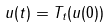Convert formula to latex. <formula><loc_0><loc_0><loc_500><loc_500>u ( t ) = T _ { t } ( u ( 0 ) )</formula> 